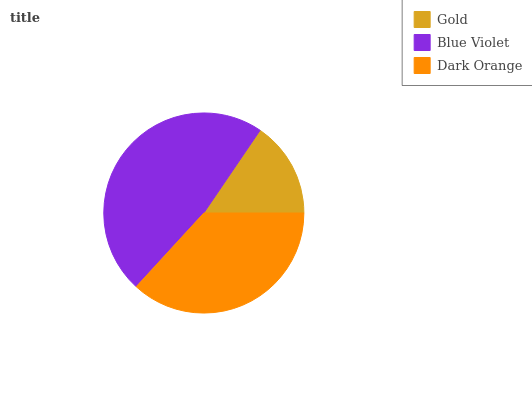Is Gold the minimum?
Answer yes or no. Yes. Is Blue Violet the maximum?
Answer yes or no. Yes. Is Dark Orange the minimum?
Answer yes or no. No. Is Dark Orange the maximum?
Answer yes or no. No. Is Blue Violet greater than Dark Orange?
Answer yes or no. Yes. Is Dark Orange less than Blue Violet?
Answer yes or no. Yes. Is Dark Orange greater than Blue Violet?
Answer yes or no. No. Is Blue Violet less than Dark Orange?
Answer yes or no. No. Is Dark Orange the high median?
Answer yes or no. Yes. Is Dark Orange the low median?
Answer yes or no. Yes. Is Blue Violet the high median?
Answer yes or no. No. Is Blue Violet the low median?
Answer yes or no. No. 